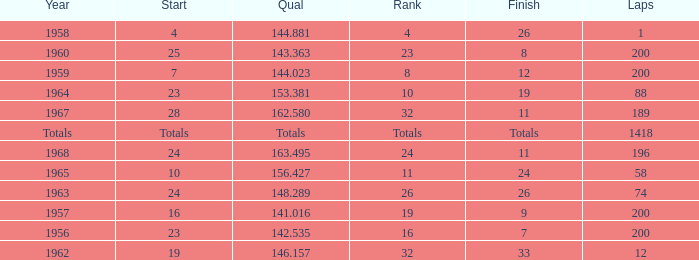Which qual has both 200 total laps and took place in 1957? 141.016. 